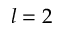<formula> <loc_0><loc_0><loc_500><loc_500>l = 2</formula> 